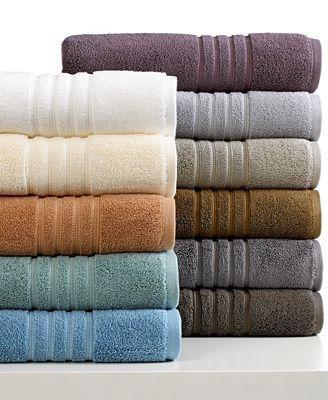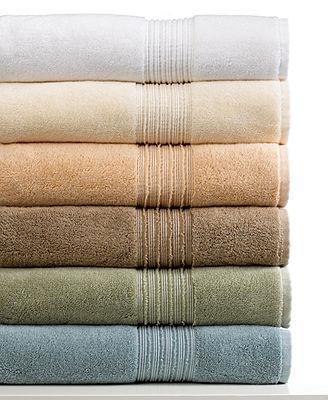The first image is the image on the left, the second image is the image on the right. Assess this claim about the two images: "The corners are pulled up on two towels.". Correct or not? Answer yes or no. No. The first image is the image on the left, the second image is the image on the right. Considering the images on both sides, is "There are two stacks of towels in the image on the right." valid? Answer yes or no. No. 